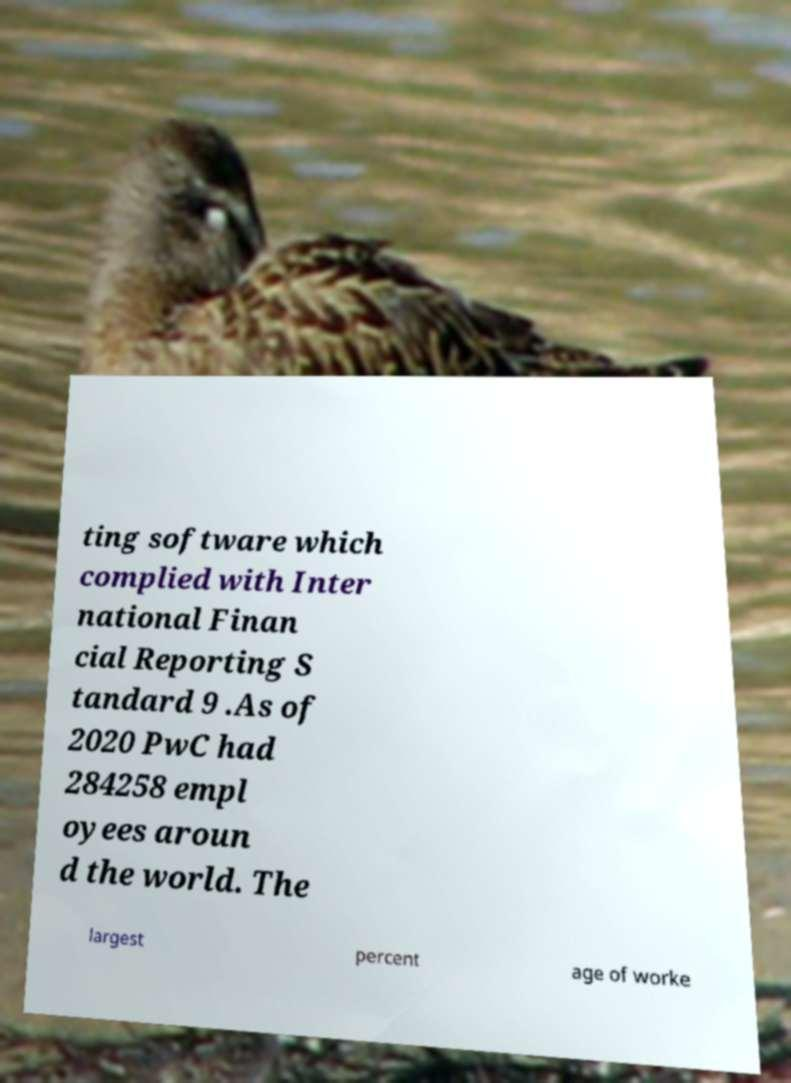Could you assist in decoding the text presented in this image and type it out clearly? ting software which complied with Inter national Finan cial Reporting S tandard 9 .As of 2020 PwC had 284258 empl oyees aroun d the world. The largest percent age of worke 